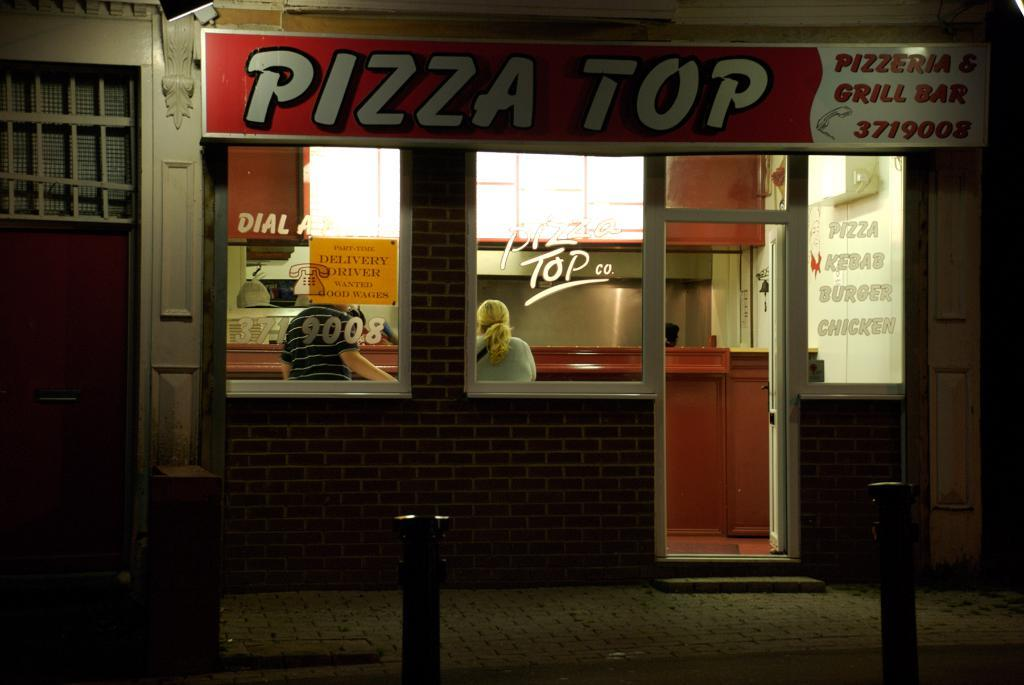How many people are in the image? There are two persons in the image. Where are the persons located? The persons are in a shop. What is in front of the persons? There is a desk before the persons. What can be seen on the pavement outside the shop? There are poles on the pavement. What is providing light in the image? There is a light attached to the wall at the top of the image. What type of appliance is sitting on the desk in the image? There is no appliance visible on the desk in the image. What color is the powder on the persons' hands in the image? There is no powder present on the persons' hands in the image. 